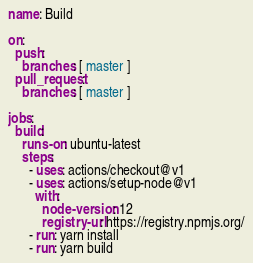Convert code to text. <code><loc_0><loc_0><loc_500><loc_500><_YAML_>name: Build

on:
  push:
    branches: [ master ]
  pull_request:
    branches: [ master ]

jobs:
  build:
    runs-on: ubuntu-latest
    steps:
      - uses: actions/checkout@v1
      - uses: actions/setup-node@v1
        with:
          node-version: 12
          registry-url: https://registry.npmjs.org/
      - run: yarn install
      - run: yarn build
</code> 